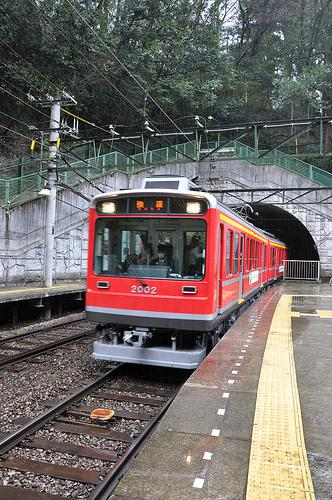Question: how many people are on the train?
Choices:
A. 3.
B. 2.
C. 9.
D. More than five.
Answer with the letter. Answer: D Question: what is the train on?
Choices:
A. Tracks.
B. On the hill.
C. On the bridge.
D. On the overpass.
Answer with the letter. Answer: A 